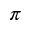Convert formula to latex. <formula><loc_0><loc_0><loc_500><loc_500>\pi</formula> 